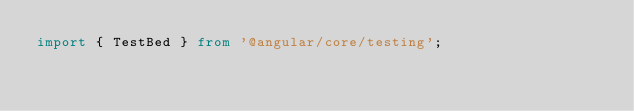<code> <loc_0><loc_0><loc_500><loc_500><_TypeScript_>import { TestBed } from '@angular/core/testing';
</code> 